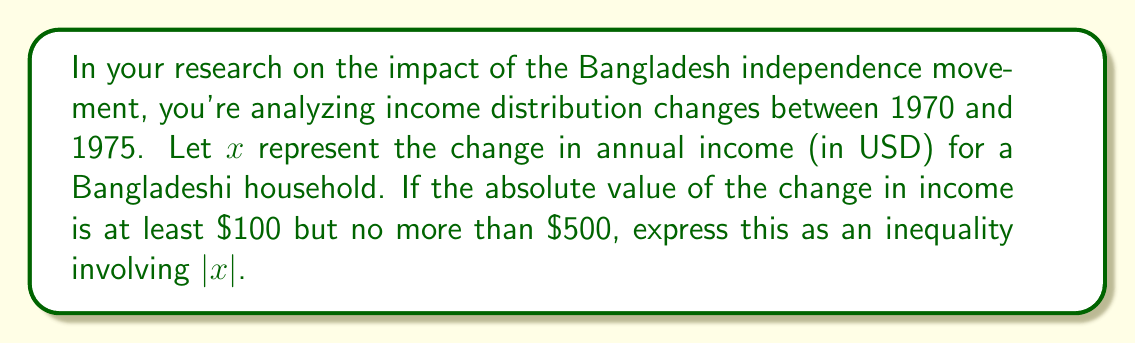Provide a solution to this math problem. Let's approach this step-by-step:

1) We need to express that the absolute value of $x$ is at least $100 and at most $500.

2) In mathematical terms, this can be written as:
   $100 \leq |x| \leq 500$

3) This compound inequality can be read as "$|x|$ is greater than or equal to 100 and less than or equal to 500."

4) We can also write this as two separate inequalities:
   $|x| \geq 100$ and $|x| \leq 500$

5) To solve this, we need to consider what $|x| \geq 100$ means:
   - If $x$ is positive, then $x \geq 100$
   - If $x$ is negative, then $-x \geq 100$, or $x \leq -100$

6) Similarly, $|x| \leq 500$ means:
   - If $x$ is positive, then $x \leq 500$
   - If $x$ is negative, then $-x \leq 500$, or $x \geq -500$

7) Combining these conditions, we get:
   $-500 \leq x \leq -100$ or $100 \leq x \leq 500$

8) However, the question asks for the inequality in terms of $|x|$, so our final answer should be:
   $100 \leq |x| \leq 500$

This inequality represents the scenario where the change in annual income for a Bangladeshi household between 1970 and 1975 was at least $100 but no more than $500, in either a positive or negative direction.
Answer: $100 \leq |x| \leq 500$ 